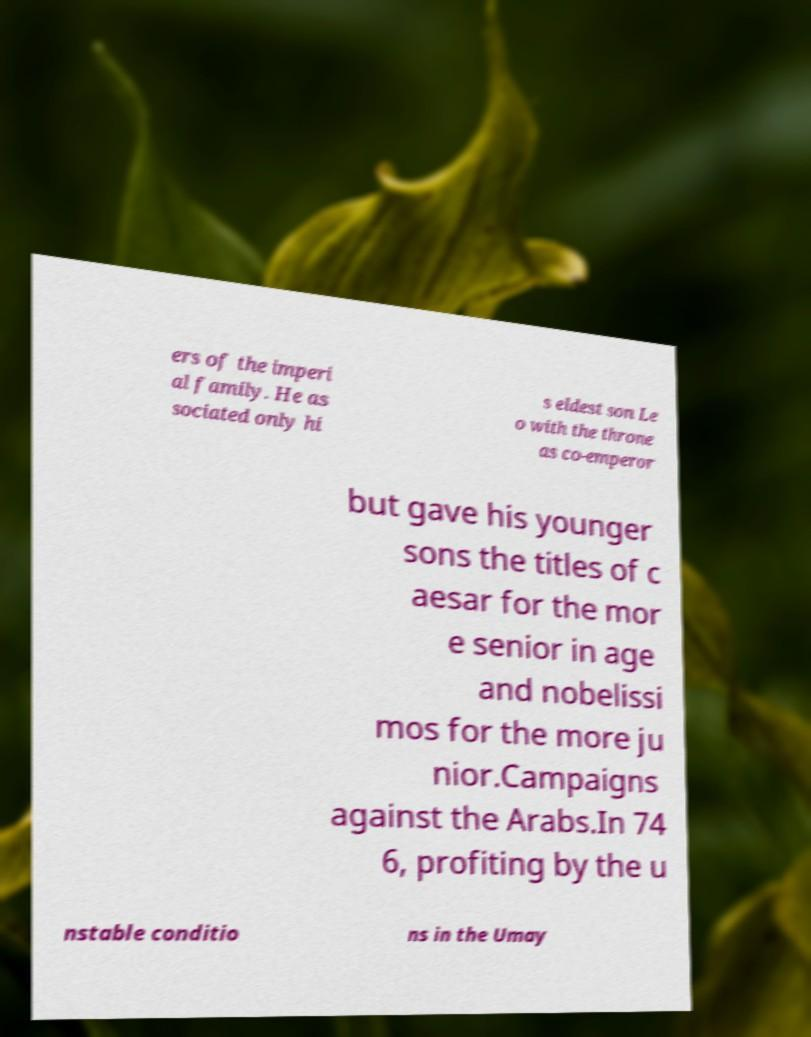Can you accurately transcribe the text from the provided image for me? ers of the imperi al family. He as sociated only hi s eldest son Le o with the throne as co-emperor but gave his younger sons the titles of c aesar for the mor e senior in age and nobelissi mos for the more ju nior.Campaigns against the Arabs.In 74 6, profiting by the u nstable conditio ns in the Umay 